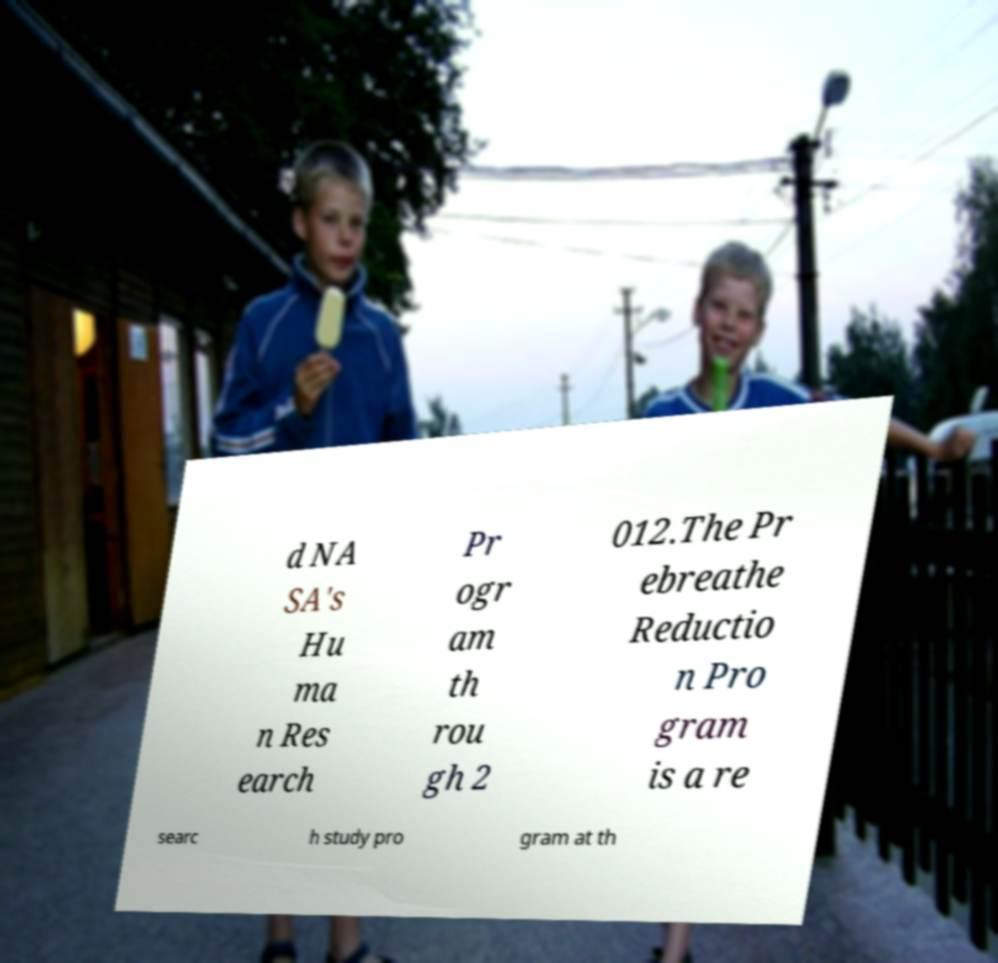Can you accurately transcribe the text from the provided image for me? d NA SA's Hu ma n Res earch Pr ogr am th rou gh 2 012.The Pr ebreathe Reductio n Pro gram is a re searc h study pro gram at th 